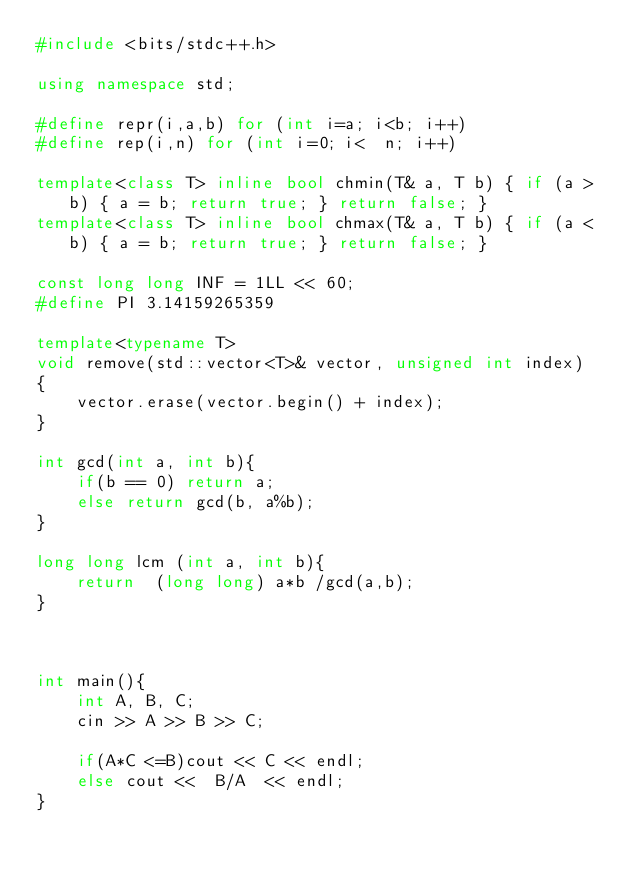<code> <loc_0><loc_0><loc_500><loc_500><_C++_>#include <bits/stdc++.h>
 
using namespace std;
 
#define repr(i,a,b) for (int i=a; i<b; i++)
#define rep(i,n) for (int i=0; i<  n; i++)
 
template<class T> inline bool chmin(T& a, T b) { if (a > b) { a = b; return true; } return false; }
template<class T> inline bool chmax(T& a, T b) { if (a < b) { a = b; return true; } return false; }
 
const long long INF = 1LL << 60;
#define PI 3.14159265359 
 
template<typename T>
void remove(std::vector<T>& vector, unsigned int index)
{
    vector.erase(vector.begin() + index);
}
 
int gcd(int a, int b){
    if(b == 0) return a;
    else return gcd(b, a%b);
}
 
long long lcm (int a, int b){
    return  (long long) a*b /gcd(a,b);
}



int main(){
    int A, B, C;
    cin >> A >> B >> C;

    if(A*C <=B)cout << C << endl;
    else cout <<  B/A  << endl;
}
</code> 